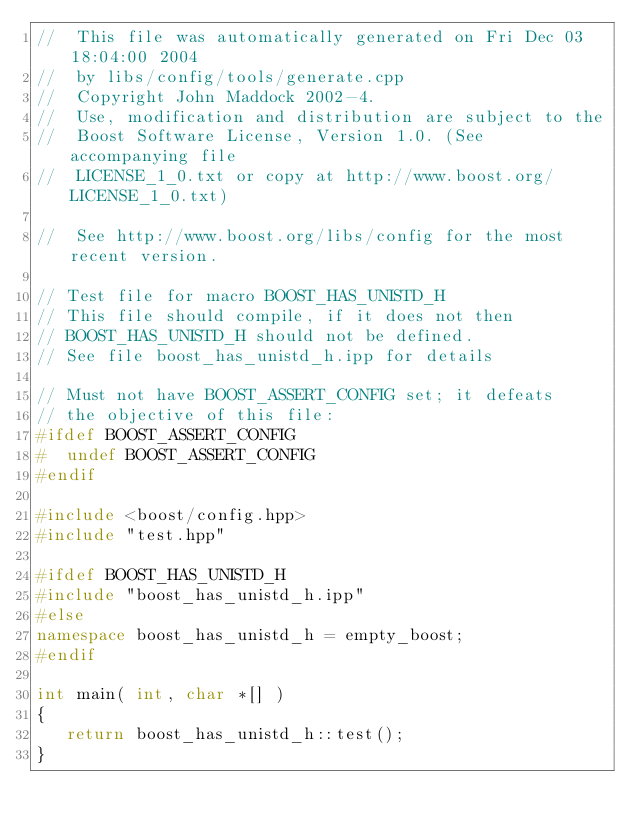<code> <loc_0><loc_0><loc_500><loc_500><_C++_>//  This file was automatically generated on Fri Dec 03 18:04:00 2004
//  by libs/config/tools/generate.cpp
//  Copyright John Maddock 2002-4.
//  Use, modification and distribution are subject to the
//  Boost Software License, Version 1.0. (See accompanying file
//  LICENSE_1_0.txt or copy at http://www.boost.org/LICENSE_1_0.txt)

//  See http://www.boost.org/libs/config for the most recent version.

// Test file for macro BOOST_HAS_UNISTD_H
// This file should compile, if it does not then
// BOOST_HAS_UNISTD_H should not be defined.
// See file boost_has_unistd_h.ipp for details

// Must not have BOOST_ASSERT_CONFIG set; it defeats
// the objective of this file:
#ifdef BOOST_ASSERT_CONFIG
#  undef BOOST_ASSERT_CONFIG
#endif

#include <boost/config.hpp>
#include "test.hpp"

#ifdef BOOST_HAS_UNISTD_H
#include "boost_has_unistd_h.ipp"
#else
namespace boost_has_unistd_h = empty_boost;
#endif

int main( int, char *[] )
{
   return boost_has_unistd_h::test();
}
</code> 